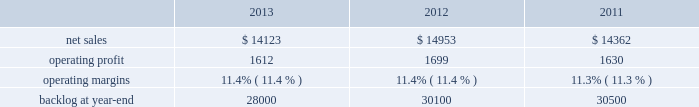Aeronautics our aeronautics business segment is engaged in the research , design , development , manufacture , integration , sustainment , support , and upgrade of advanced military aircraft , including combat and air mobility aircraft , unmanned air vehicles , and related technologies .
Aeronautics 2019 major programs include the f-35 lightning ii joint strike fighter , c-130 hercules , f-16 fighting falcon , f-22 raptor , and the c-5m super galaxy .
Aeronautics 2019 operating results included the following ( in millions ) : .
2013 compared to 2012 aeronautics 2019 net sales for 2013 decreased $ 830 million , or 6% ( 6 % ) , compared to 2012 .
The decrease was primarily attributable to lower net sales of approximately $ 530 million for the f-16 program due to fewer aircraft deliveries ( 13 aircraft delivered in 2013 compared to 37 delivered in 2012 ) partially offset by aircraft configuration mix ; about $ 385 million for the c-130 program due to fewer aircraft deliveries ( 25 aircraft delivered in 2013 compared to 34 in 2012 ) partially offset by increased sustainment activities ; approximately $ 255 million for the f-22 program , which includes about $ 205 million due to decreased production volume as final aircraft deliveries were completed during the second quarter of 2012 and $ 50 million from the favorable resolution of a contractual matter during the second quarter of 2012 ; and about $ 270 million for various other programs ( primarily sustainment activities ) due to decreased volume .
The decreases were partially offset by higher net sales of about $ 295 million for f-35 production contracts due to increased production volume and risk retirements ; approximately $ 245 million for the c-5 program due to increased aircraft deliveries ( six aircraft delivered in 2013 compared to four in 2012 ) and other modernization activities ; and about $ 70 million for the f-35 development contract due to increased volume .
Aeronautics 2019 operating profit for 2013 decreased $ 87 million , or 5% ( 5 % ) , compared to 2012 .
The decrease was primarily attributable to lower operating profit of about $ 85 million for the f-22 program , which includes approximately $ 50 million from the favorable resolution of a contractual matter in the second quarter of 2012 and about $ 35 million due to decreased risk retirements and production volume ; approximately $ 70 million for the c-130 program due to lower risk retirements and fewer deliveries partially offset by increased sustainment activities ; about $ 65 million for the c-5 program due to the inception-to-date effect of reducing the profit booking rate in the third quarter of 2013 and lower risk retirements ; approximately $ 35 million for the f-16 program due to fewer aircraft deliveries partially offset by increased sustainment activity and aircraft configuration mix .
The decreases were partially offset by higher operating profit of approximately $ 180 million for f-35 production contracts due to increased risk retirements and volume .
Operating profit was comparable for the f-35 development contract and included adjustments of approximately $ 85 million to reflect the inception-to-date impacts of the downward revisions to the profit booking rate in both 2013 and 2012 .
Adjustments not related to volume , including net profit booking rate adjustments and other matters , were approximately $ 75 million lower for 2013 compared to 2012 compared to 2011 aeronautics 2019 net sales for 2012 increased $ 591 million , or 4% ( 4 % ) , compared to 2011 .
The increase was attributable to higher net sales of approximately $ 745 million from f-35 production contracts principally due to increased production volume ; about $ 285 million from f-16 programs primarily due to higher aircraft deliveries ( 37 f-16 aircraft delivered in 2012 compared to 22 in 2011 ) partially offset by lower volume on sustainment activities due to the completion of modification programs for certain international customers ; and approximately $ 140 million from c-5 programs due to higher aircraft deliveries ( four c-5m aircraft delivered in 2012 compared to two in 2011 ) .
Partially offsetting the increases were lower net sales of approximately $ 365 million from decreased production volume and lower risk retirements on the f-22 program as final aircraft deliveries were completed in the second quarter of 2012 ; approximately $ 110 million from the f-35 development contract primarily due to the inception-to-date effect of reducing the profit booking rate in the second quarter of 2012 and to a lesser extent lower volume ; and about $ 95 million from a decrease in volume on other sustainment activities partially offset by various other aeronautics programs due to higher volume .
Net sales for c-130 programs were comparable to 2011 as a decline in sustainment activities largely was offset by increased aircraft deliveries. .
What was the average net sales in millions for aeronautics from 2001 to 2013? 
Computations: table_average(net sales, none)
Answer: 14479.33333. 